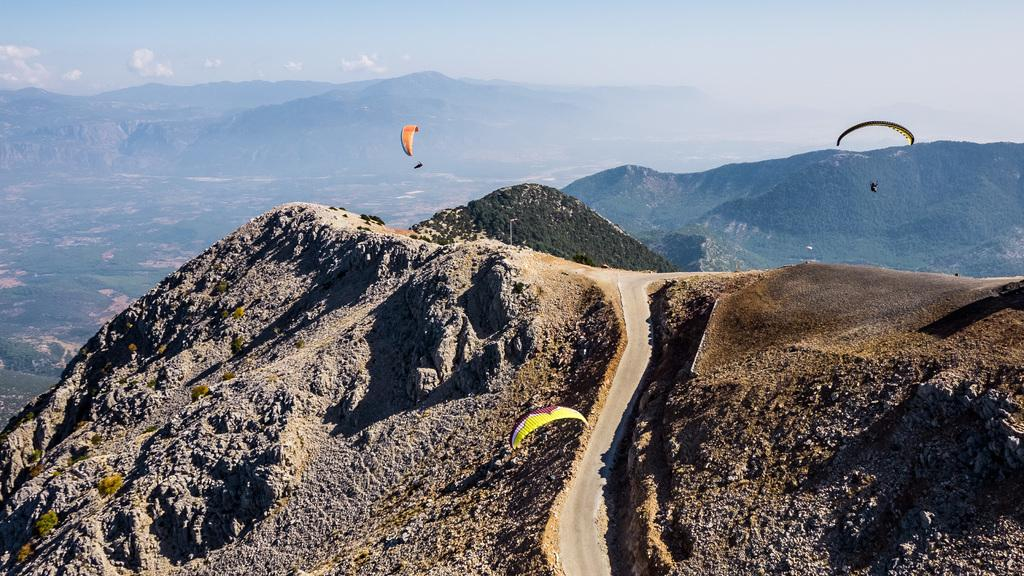What objects are present in the image that are used for descending from a height? There are parachutes in the image. What type of subjects can be seen in the image? There are persons in the image. What type of man-made structure can be seen in the image? There is a road in the image. What type of natural features can be seen in the image? There are hills and trees in the image. What part of the natural environment is visible in the image? The sky is visible in the image, and there are clouds present. What type of animal can be seen grazing on the grass near the road in the image? There are no animals visible in the image, including deer. How does the sound of the parachutes opening affect the hearing of the persons in the image? The image does not provide any information about the sound of the parachutes opening or its effect on the persons' hearing. 